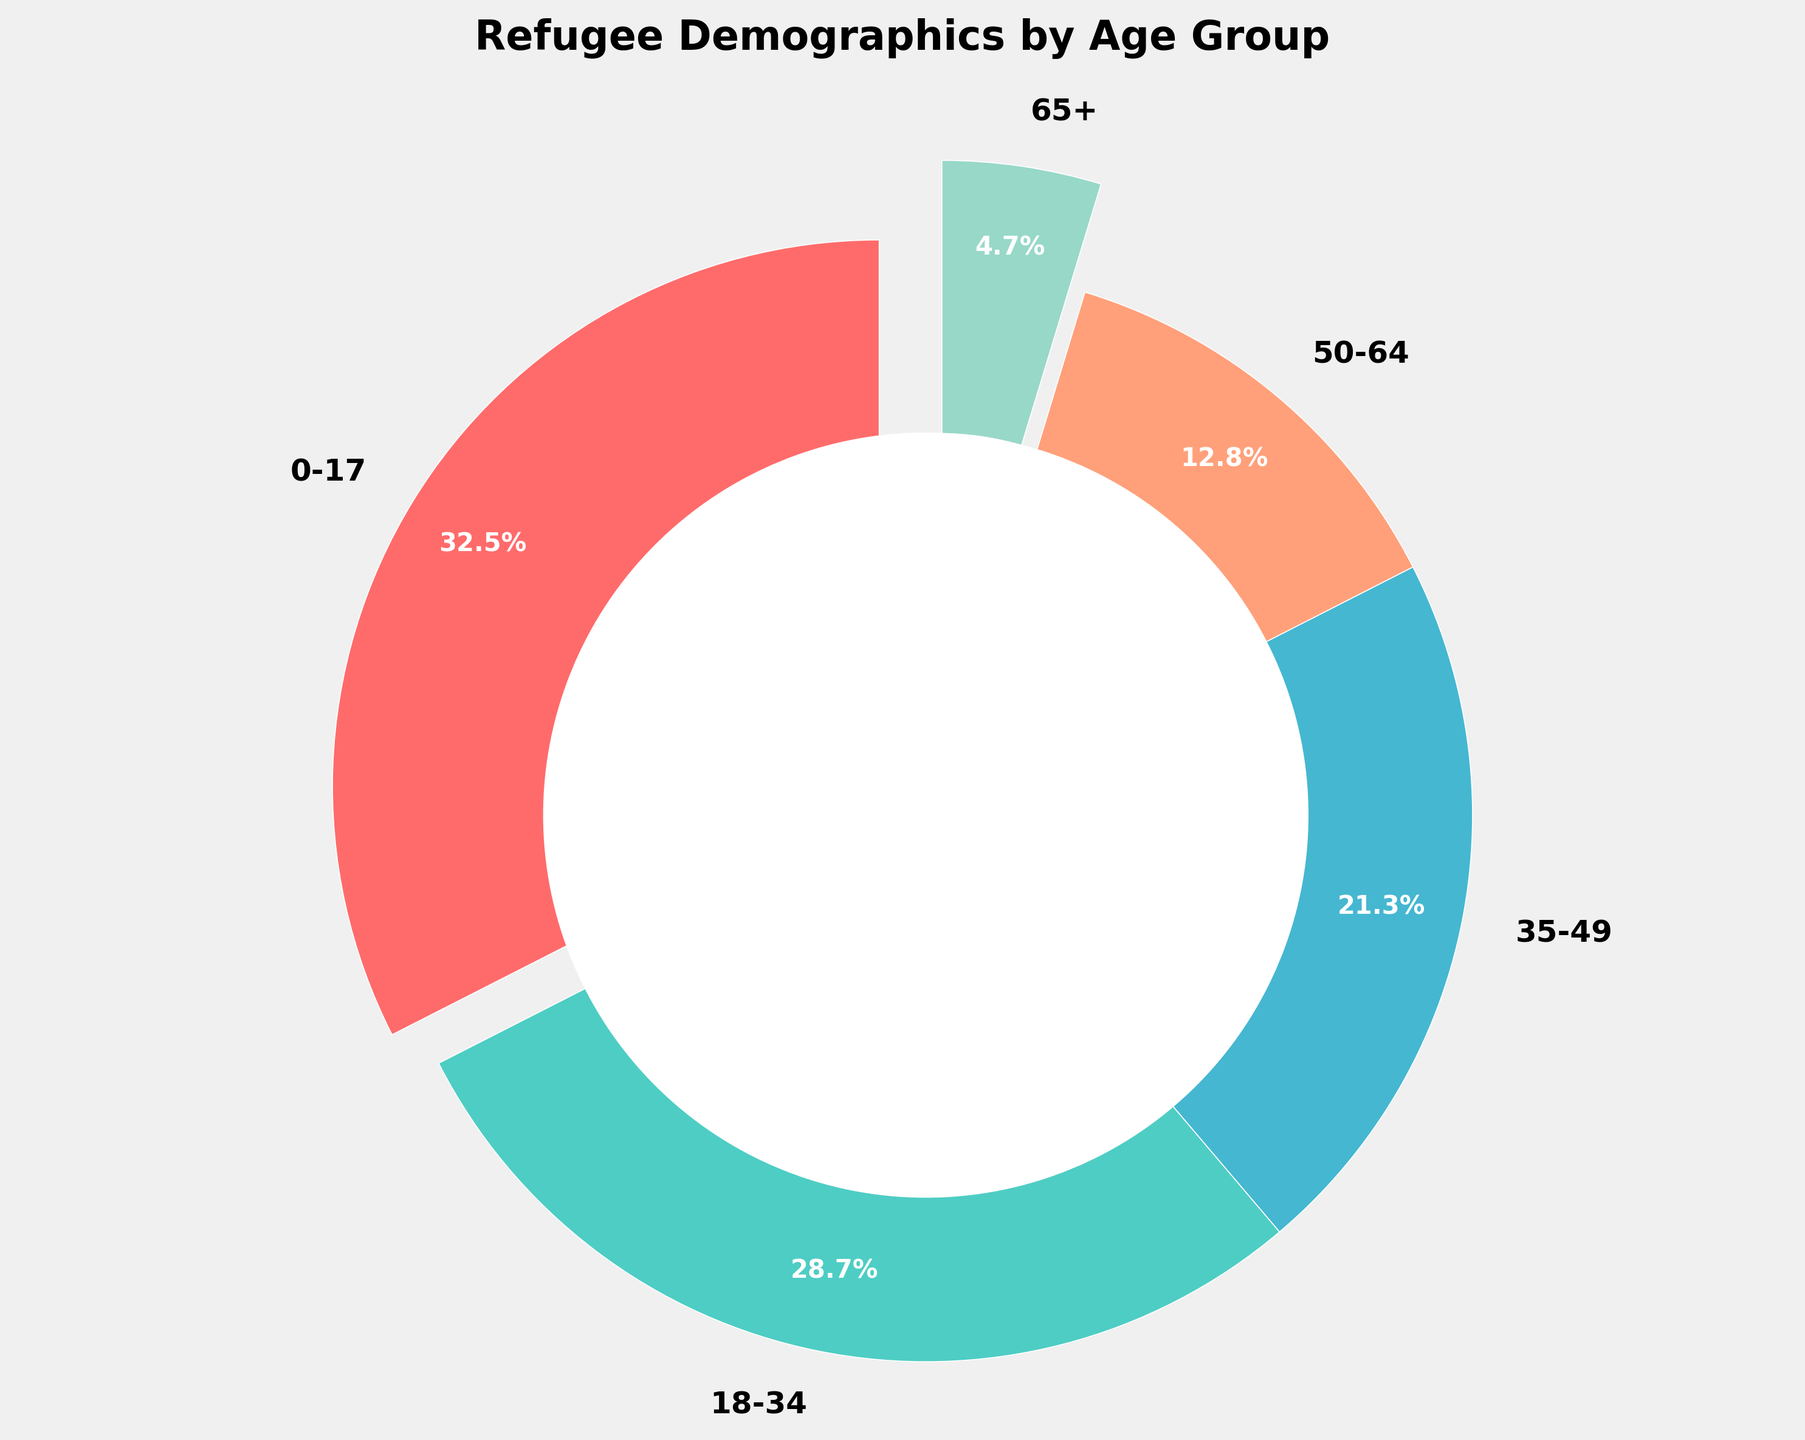What percentage of refugees are aged 18-34? Locate the 18-34 age group slice in the pie chart and read off the percentage value.
Answer: 28.7% Which age group has the smallest percentage of refugees? Compare the sizes of the slices in the pie chart and identify which has the smallest percentage.
Answer: 65+ What is the combined percentage of refugees aged 0-17 and 18-34? Add the percentages of the 0-17 and 18-34 age groups (32.5 + 28.7).
Answer: 61.2% Which age group has a higher percentage of refugees: 35-49 or 50-64? Compare the percentages for the 35-49 and 50-64 age groups. 35-49 has 21.3% and 50-64 has 12.8%.
Answer: 35-49 What is the total percentage of refugees above the age of 34? Add the percentages of the 35-49, 50-64, and 65+ age groups (21.3 + 12.8 + 4.7).
Answer: 38.8% By how much does the percentage of the 0-17 age group exceed the 50-64 age group? Subtract the percentage of the 50-64 age group from the percentage of the 0-17 age group (32.5 - 12.8).
Answer: 19.7% Is the 18-34 age group larger than the combined 50-64 and 65+ age groups? Compare the percentage of the 18-34 age group (28.7%) to the sum of the percentages for 50-64 and 65+ (12.8 + 4.7 = 17.5%).
Answer: Yes Which slice in the pie chart is colored red? Identify the colors of the slices and match them to the age group data.
Answer: 0-17 What is the average percentage of refugees in the age groups 35-49, 50-64, and 65+? Add the percentages of the 35-49, 50-64, and 65+ age groups and divide by 3 ((21.3 + 12.8 + 4.7) / 3).
Answer: 12.93% 